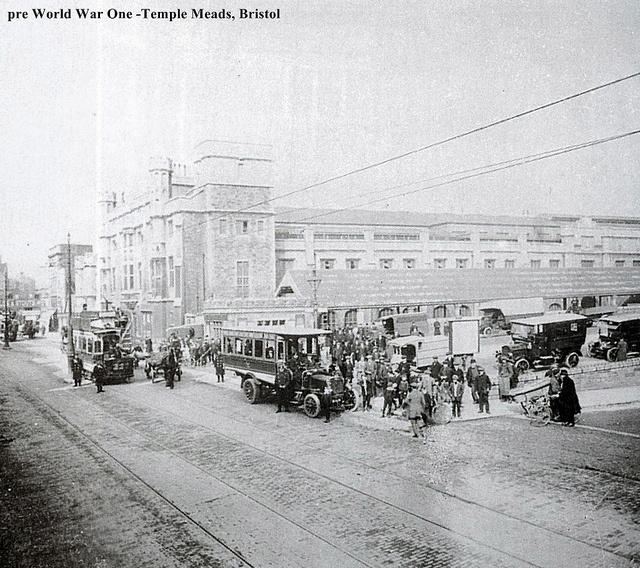Describe the objects in this image and their specific colors. I can see bus in lightgray, black, gray, and darkgray tones, car in lightgray, black, gray, and darkgray tones, bus in lightgray, black, gray, and darkgray tones, truck in lightgray, darkgray, gray, and black tones, and truck in lightgray, darkgray, black, and gray tones in this image. 